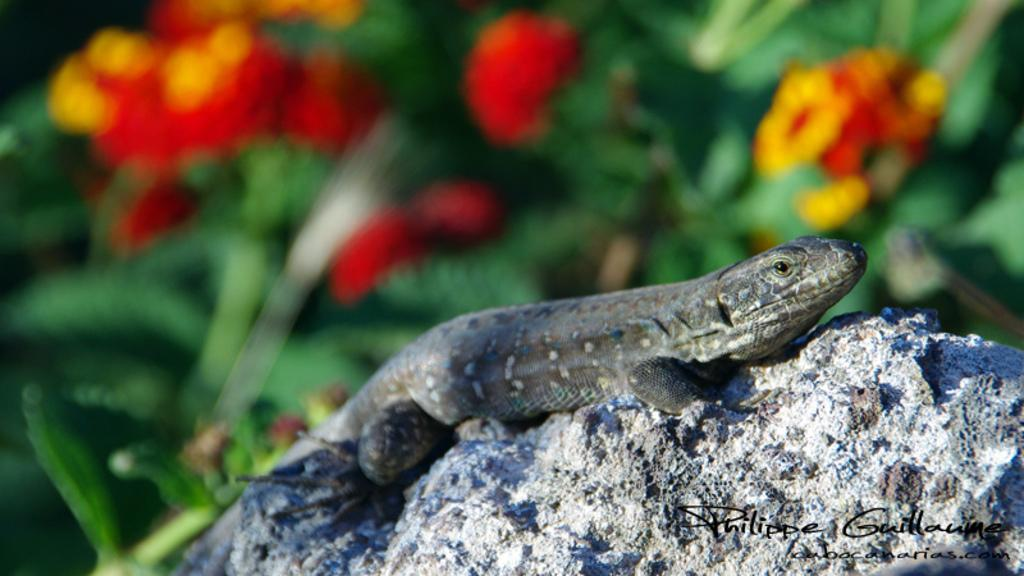What animal can be seen on a stone in the image? There is a lizard visible on a stone in the image. What type of vegetation is present in the background of the image? There are flowers and trees in the background of the image. How many feet does the lizard have in the image? The number of feet the lizard has cannot be determined from the image alone, as it is not possible to count them accurately. 